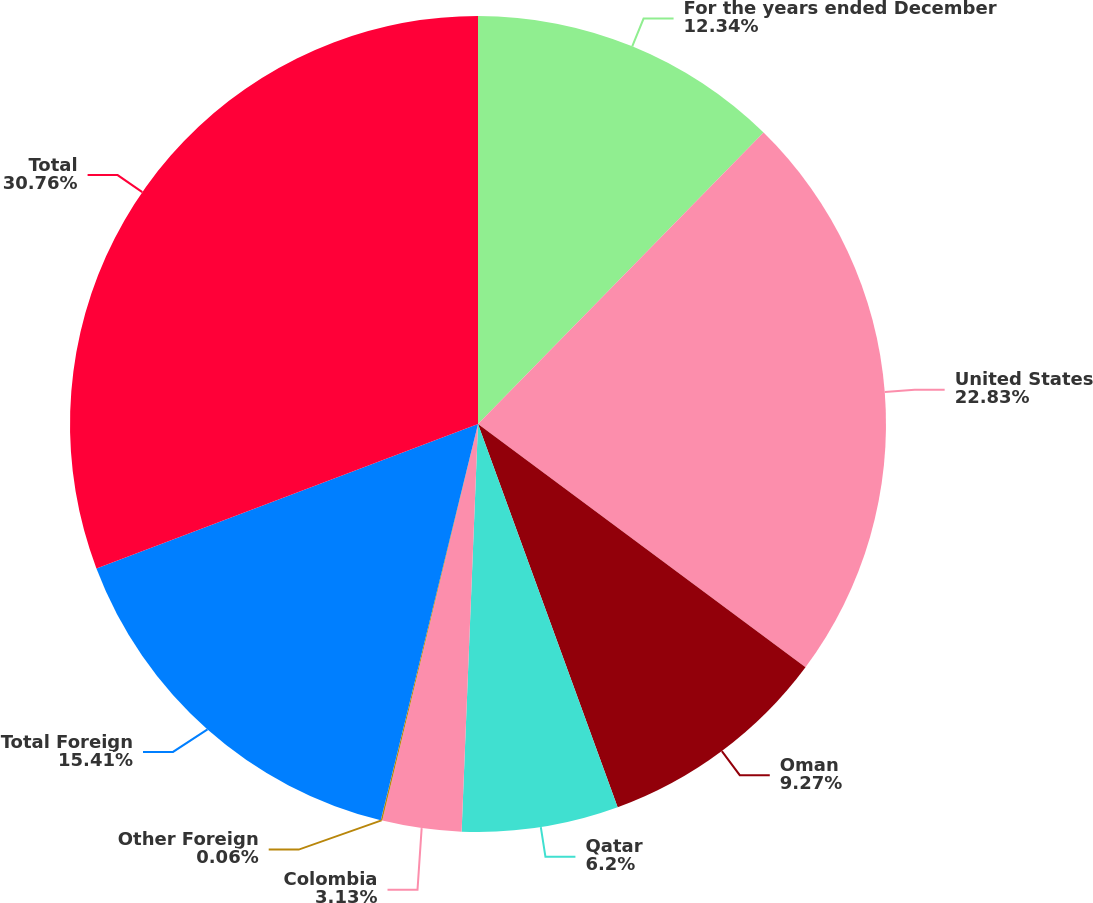Convert chart to OTSL. <chart><loc_0><loc_0><loc_500><loc_500><pie_chart><fcel>For the years ended December<fcel>United States<fcel>Oman<fcel>Qatar<fcel>Colombia<fcel>Other Foreign<fcel>Total Foreign<fcel>Total<nl><fcel>12.34%<fcel>22.83%<fcel>9.27%<fcel>6.2%<fcel>3.13%<fcel>0.06%<fcel>15.41%<fcel>30.76%<nl></chart> 